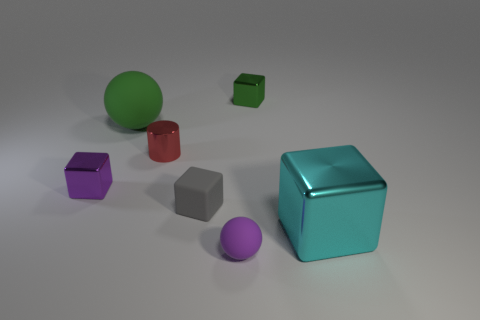Subtract all cyan metal blocks. How many blocks are left? 3 Subtract all purple cubes. How many cubes are left? 3 Subtract all red blocks. Subtract all cyan cylinders. How many blocks are left? 4 Add 1 red cylinders. How many objects exist? 8 Subtract all balls. How many objects are left? 5 Subtract all large things. Subtract all big purple metal cubes. How many objects are left? 5 Add 2 blocks. How many blocks are left? 6 Add 6 purple matte spheres. How many purple matte spheres exist? 7 Subtract 1 green spheres. How many objects are left? 6 